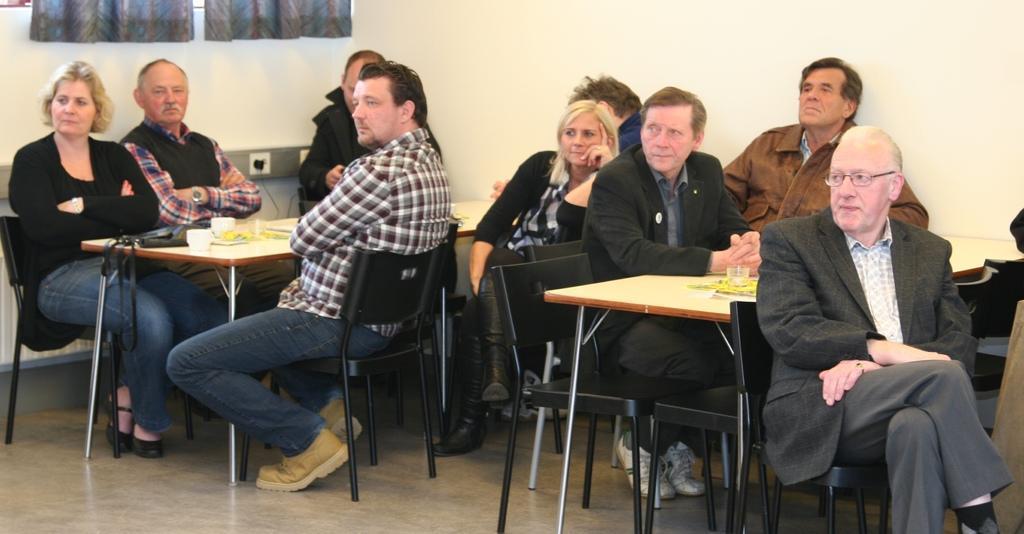Could you give a brief overview of what you see in this image? On the background we can see wall and curtains. We can see all the persons sitting on chairs in front of a table and on the table we can see glass, cups. This is a floor. 